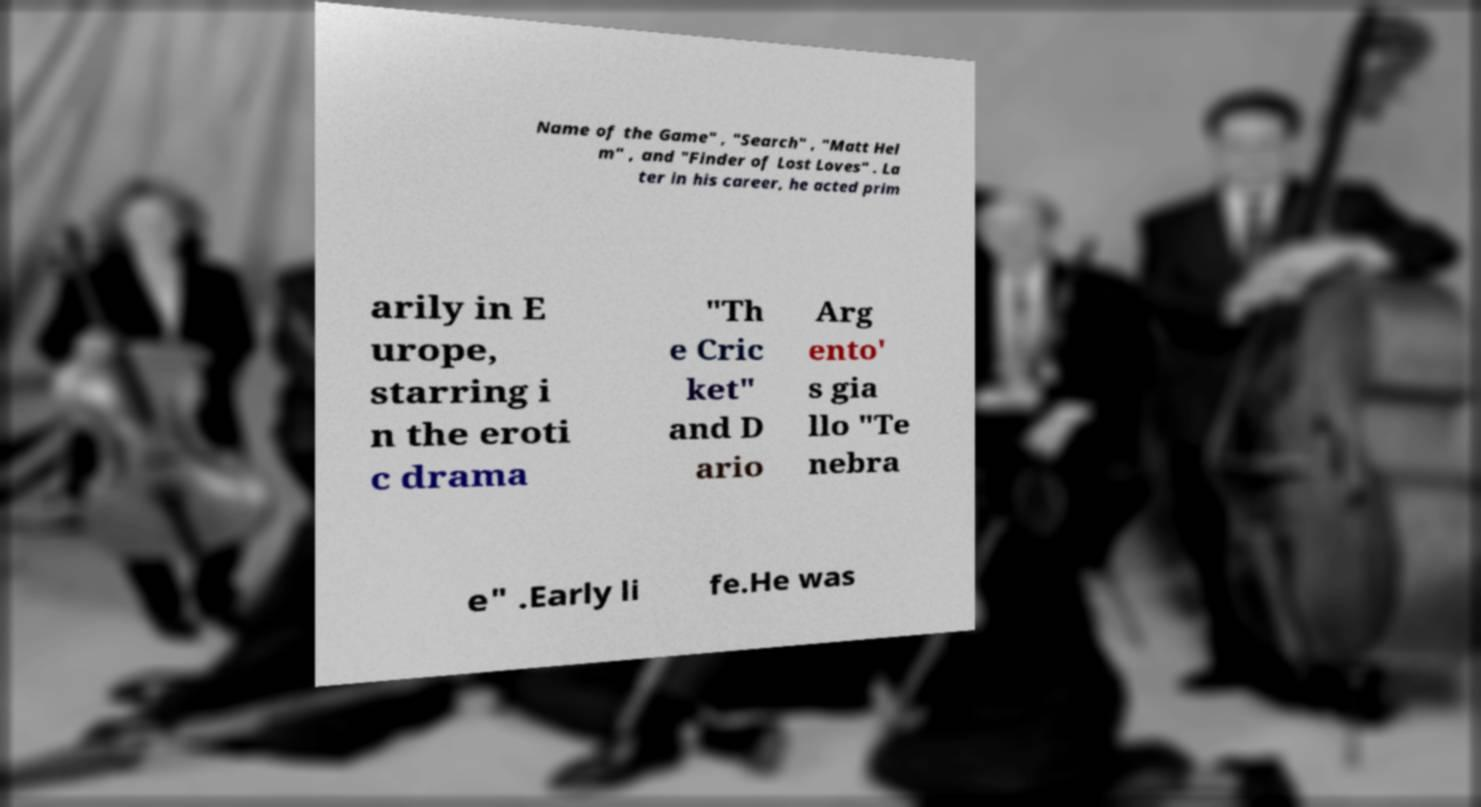For documentation purposes, I need the text within this image transcribed. Could you provide that? Name of the Game" , "Search" , "Matt Hel m" , and "Finder of Lost Loves" . La ter in his career, he acted prim arily in E urope, starring i n the eroti c drama "Th e Cric ket" and D ario Arg ento' s gia llo "Te nebra e" .Early li fe.He was 